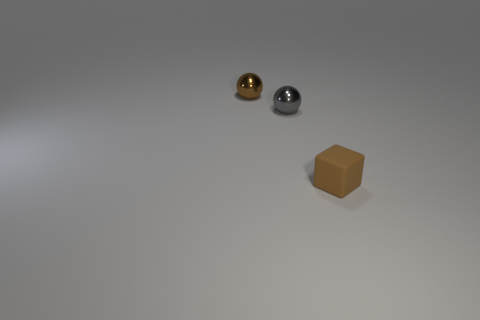What size is the metallic object that is the same color as the cube?
Make the answer very short. Small. Is the number of matte cubes right of the small brown metal sphere less than the number of small brown metallic spheres that are behind the matte object?
Provide a short and direct response. No. Is there anything else that is the same color as the block?
Your answer should be compact. Yes. There is a small brown metallic object; what shape is it?
Your response must be concise. Sphere. There is another ball that is made of the same material as the gray sphere; what color is it?
Your answer should be very brief. Brown. Is the number of large blocks greater than the number of brown things?
Offer a terse response. No. Is there a small rubber cube?
Your response must be concise. Yes. The metal thing that is on the right side of the brown thing behind the cube is what shape?
Your response must be concise. Sphere. How many things are either small cyan objects or small things that are on the left side of the brown rubber object?
Provide a short and direct response. 2. There is a small shiny sphere right of the small brown object that is behind the small brown object in front of the brown sphere; what is its color?
Offer a very short reply. Gray. 